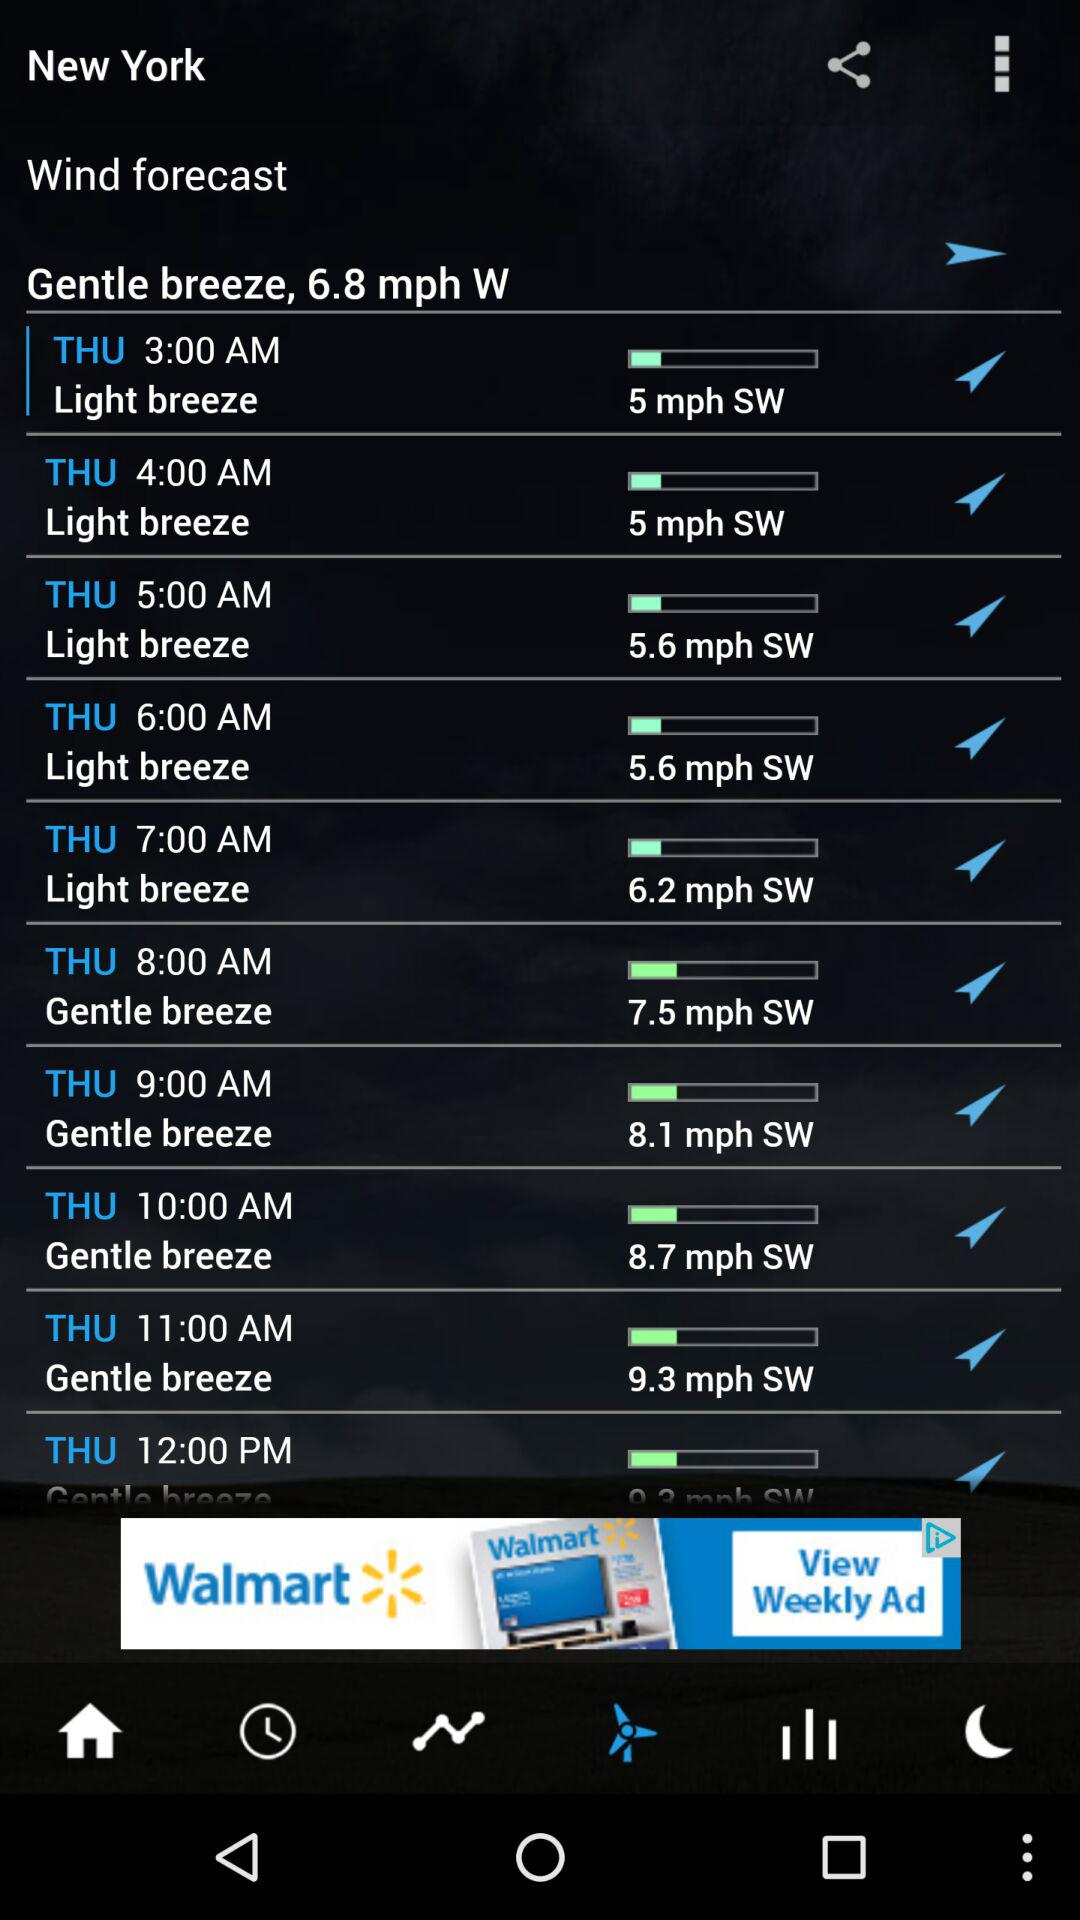How is the breeze on Thursday at 6 am? It is "Light breeze". 